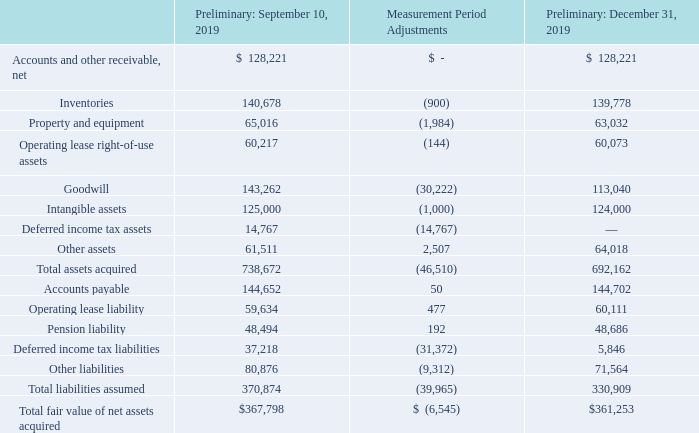ADVANCED ENERGY INDUSTRIES, INC. NOTES TO CONSOLIDATED FINANCIAL STATEMENTS – (continued) (in thousands, except per share amounts)
The following table summarizes the estimated preliminary fair values of the assets acquired and liabilities assumed from the acquisition in 2019:
What does the table show? Summarizes the estimated preliminary fair values of the assets acquired and liabilities assumed from the acquisition in 2019. What was the Preliminary fair value of property and equipment in December 31, 2019?
Answer scale should be: thousand. 63,032. What was the Preliminary fair value of inventories in September 10, 2019?
Answer scale should be: thousand. 140,678. What was the Preliminary percentage change of total liabilities assumed between September and December 2019?
Answer scale should be: percent. (330,909-370,874)/370,874
Answer: -10.78. What was the Preliminary percentage change of total fair value of net assets acquired between September and December 2019?
Answer scale should be: percent. ($361,253-$367,798)/$367,798
Answer: -1.78. What was the Preliminary percentage change of other liabilities between September and December 2019?
Answer scale should be: percent. (71,564-80,876)/80,876
Answer: -11.51. 